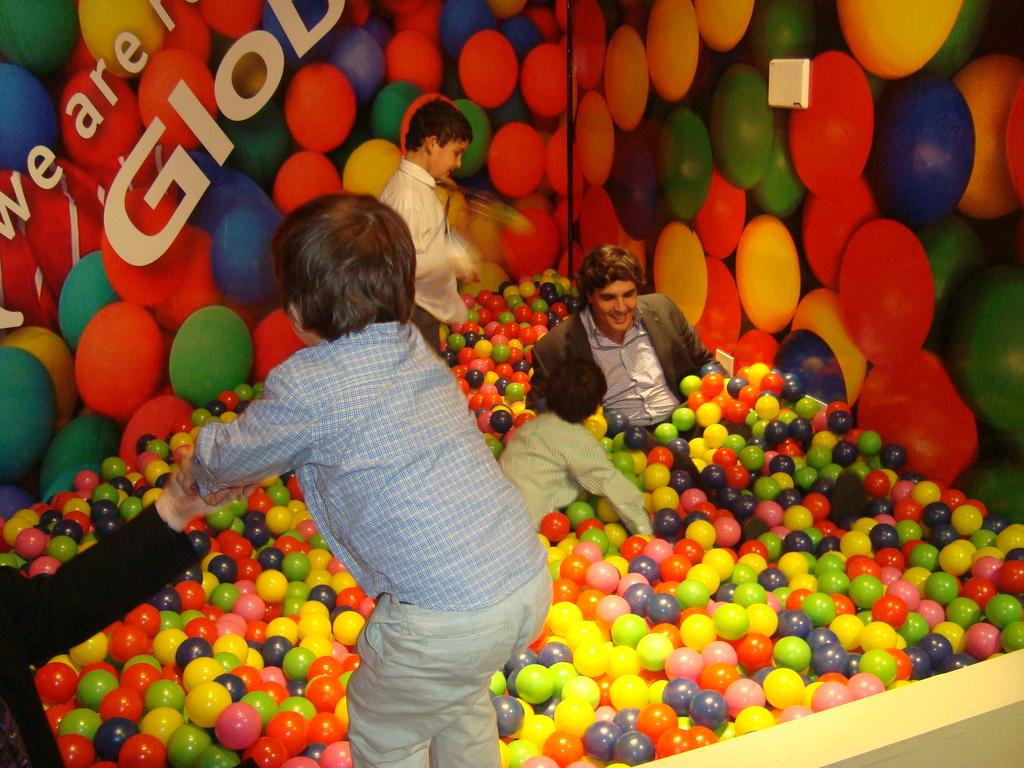What type of play area is featured in the image? There is a fun ball pit in the image. What are the people in the image doing? The people are playing in the ball pit. What can be seen in the background of the image? There is a colorful wall in the background of the image. How many eggs are hidden in the ball pit in the image? There is no mention of eggs in the image; it features a fun ball pit with people playing. 